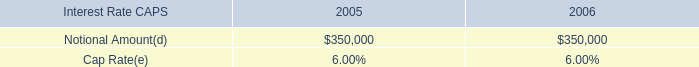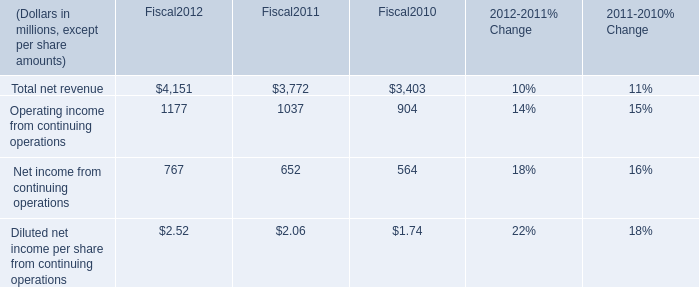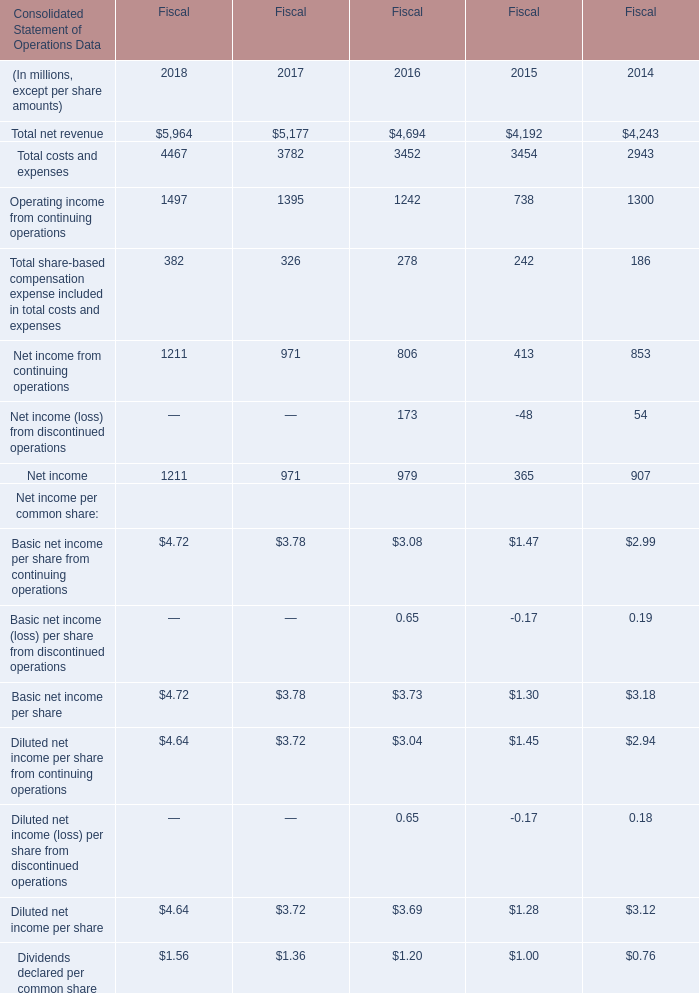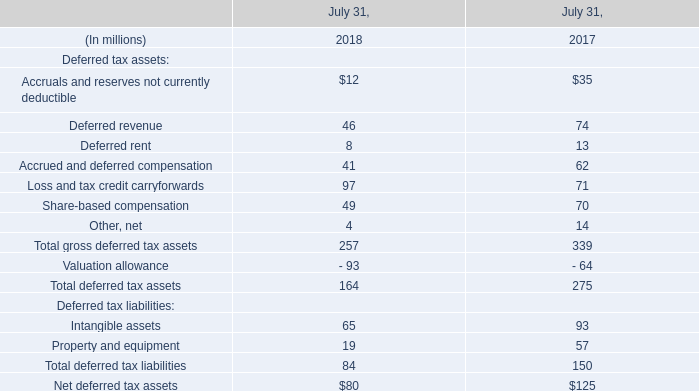What was the average of the Net income in the years where Net income (loss) from discontinued operations is positive? (in million) 
Computations: ((979 + 907) / 2)
Answer: 943.0. 